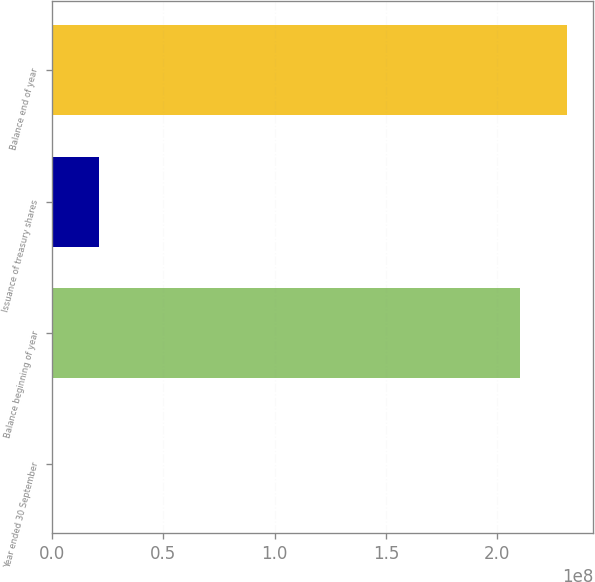<chart> <loc_0><loc_0><loc_500><loc_500><bar_chart><fcel>Year ended 30 September<fcel>Balance beginning of year<fcel>Issuance of treasury shares<fcel>Balance end of year<nl><fcel>2012<fcel>2.10185e+08<fcel>2.12494e+07<fcel>2.31433e+08<nl></chart> 